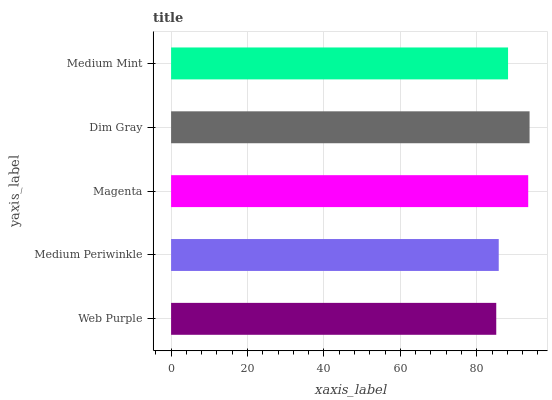Is Web Purple the minimum?
Answer yes or no. Yes. Is Dim Gray the maximum?
Answer yes or no. Yes. Is Medium Periwinkle the minimum?
Answer yes or no. No. Is Medium Periwinkle the maximum?
Answer yes or no. No. Is Medium Periwinkle greater than Web Purple?
Answer yes or no. Yes. Is Web Purple less than Medium Periwinkle?
Answer yes or no. Yes. Is Web Purple greater than Medium Periwinkle?
Answer yes or no. No. Is Medium Periwinkle less than Web Purple?
Answer yes or no. No. Is Medium Mint the high median?
Answer yes or no. Yes. Is Medium Mint the low median?
Answer yes or no. Yes. Is Medium Periwinkle the high median?
Answer yes or no. No. Is Web Purple the low median?
Answer yes or no. No. 